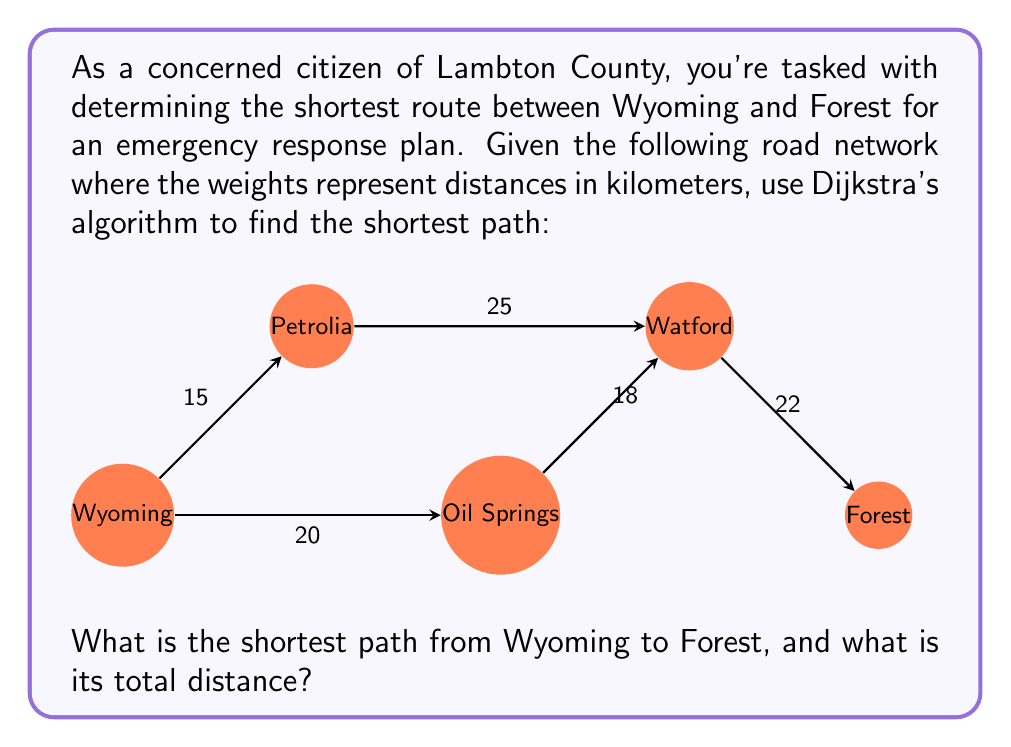Can you solve this math problem? To solve this problem, we'll use Dijkstra's algorithm, which is an efficient method for finding the shortest path between nodes in a graph.

Step 1: Initialize the algorithm
- Set the distance to Wyoming (start node) as 0.
- Set the distance to all other nodes as infinity.
- Create a set of unvisited nodes containing all nodes.

Step 2: For the current node (starting with Wyoming), consider all its unvisited neighbors and calculate their tentative distances.
- Wyoming to Petrolia: 15 km
- Wyoming to Oil Springs: 20 km

Step 3: When we've considered all neighbors of the current node, mark it as visited and remove it from the unvisited set.

Step 4: If the destination node (Forest) has been marked visited, we're done. Otherwise, select the unvisited node with the smallest tentative distance and set it as the new current node. Go back to step 2.

Following these steps:

1. Start at Wyoming (0 km)
2. Move to Petrolia (15 km)
3. From Petrolia to Watford (15 + 25 = 40 km)
4. From Watford to Forest (40 + 22 = 62 km)

We could also consider the path:
Wyoming -> Oil Springs -> Watford -> Forest
But this would be longer: 20 + 18 + 22 = 60 km

Therefore, the shortest path is:
Wyoming -> Petrolia -> Watford -> Forest

The total distance can be calculated as:
$$15 + 25 + 22 = 62\text{ km}$$
Answer: The shortest path from Wyoming to Forest is Wyoming -> Petrolia -> Watford -> Forest, with a total distance of 62 km. 